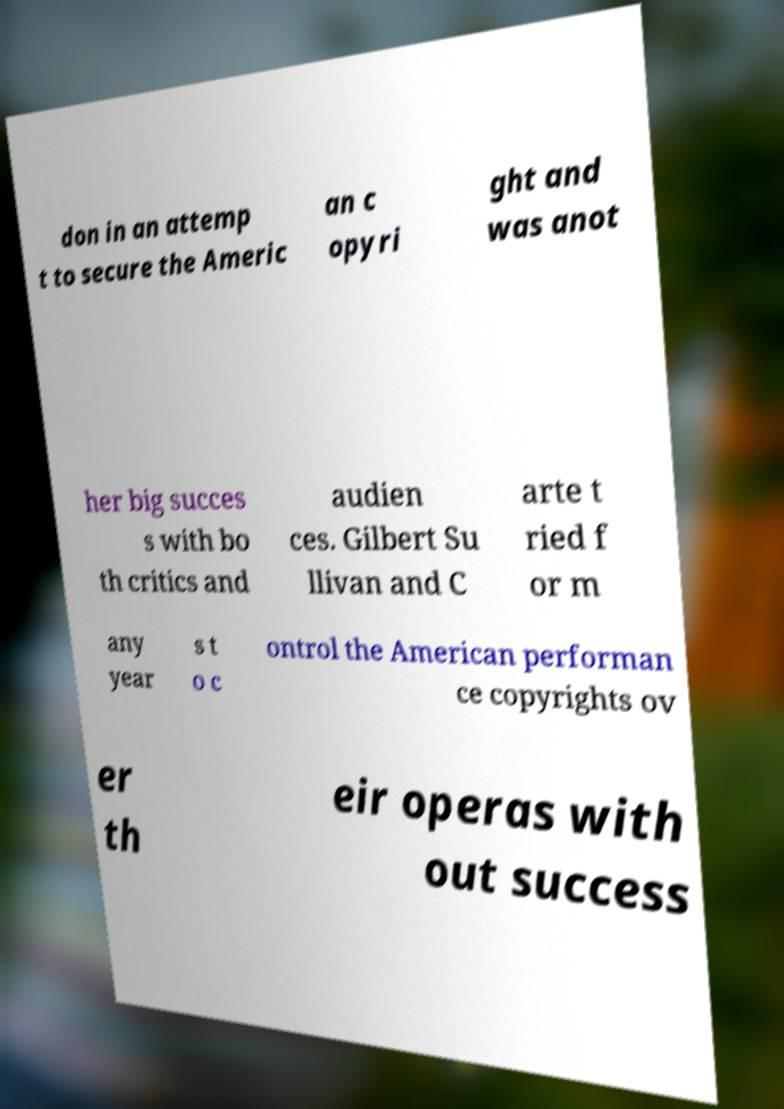Could you assist in decoding the text presented in this image and type it out clearly? don in an attemp t to secure the Americ an c opyri ght and was anot her big succes s with bo th critics and audien ces. Gilbert Su llivan and C arte t ried f or m any year s t o c ontrol the American performan ce copyrights ov er th eir operas with out success 